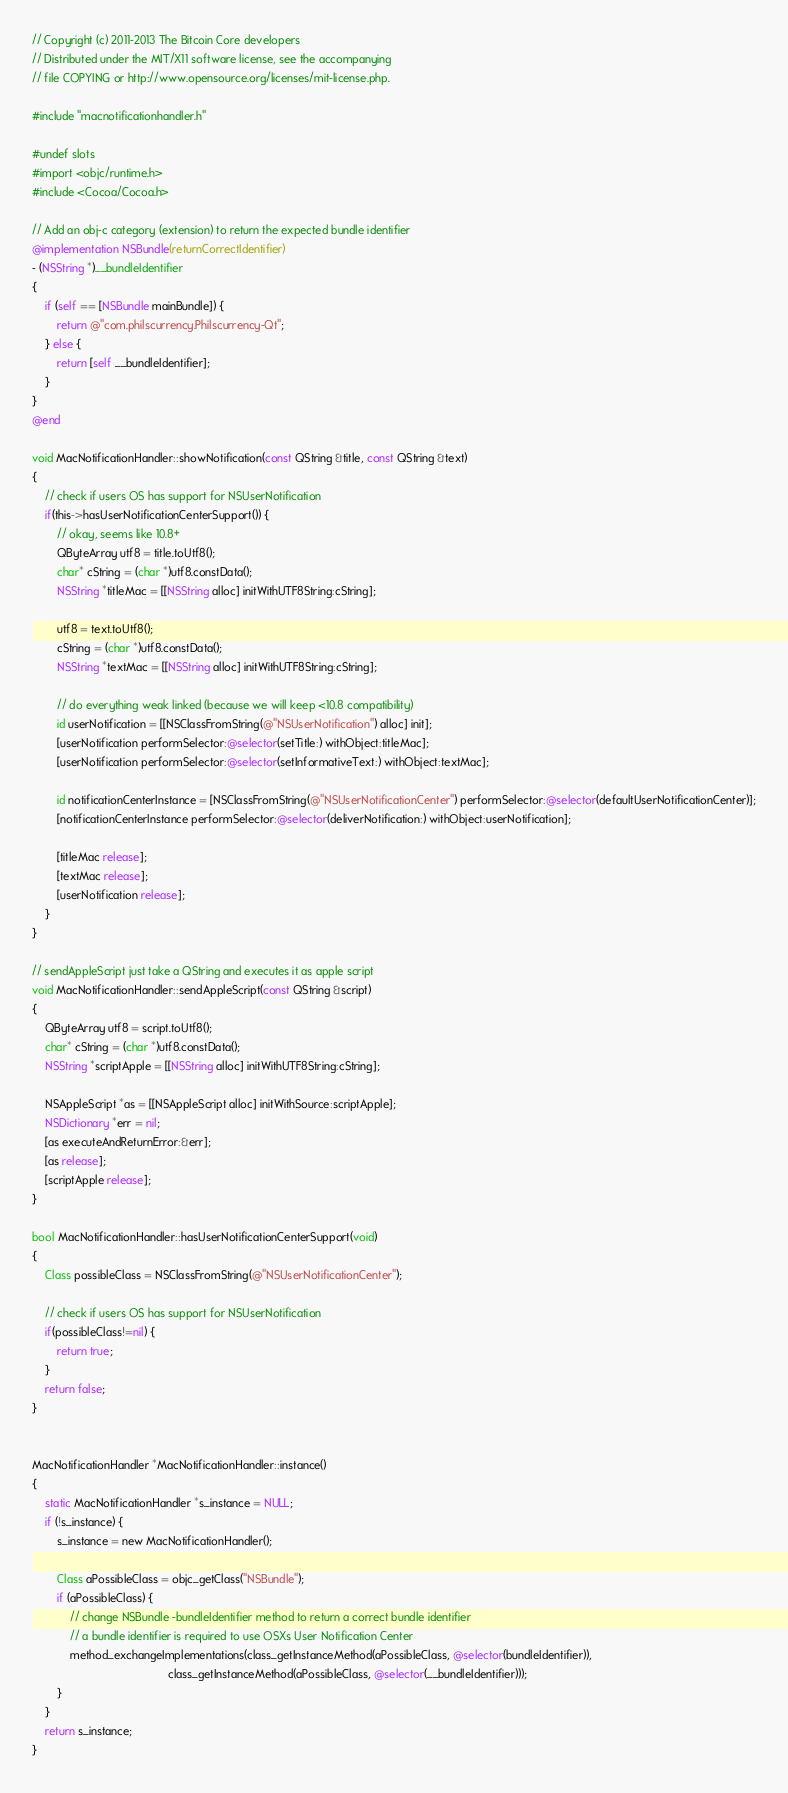<code> <loc_0><loc_0><loc_500><loc_500><_ObjectiveC_>// Copyright (c) 2011-2013 The Bitcoin Core developers
// Distributed under the MIT/X11 software license, see the accompanying
// file COPYING or http://www.opensource.org/licenses/mit-license.php.

#include "macnotificationhandler.h"

#undef slots
#import <objc/runtime.h>
#include <Cocoa/Cocoa.h>

// Add an obj-c category (extension) to return the expected bundle identifier
@implementation NSBundle(returnCorrectIdentifier)
- (NSString *)__bundleIdentifier
{
    if (self == [NSBundle mainBundle]) {
        return @"com.philscurrency.Philscurrency-Qt";
    } else {
        return [self __bundleIdentifier];
    }
}
@end

void MacNotificationHandler::showNotification(const QString &title, const QString &text)
{
    // check if users OS has support for NSUserNotification
    if(this->hasUserNotificationCenterSupport()) {
        // okay, seems like 10.8+
        QByteArray utf8 = title.toUtf8();
        char* cString = (char *)utf8.constData();
        NSString *titleMac = [[NSString alloc] initWithUTF8String:cString];

        utf8 = text.toUtf8();
        cString = (char *)utf8.constData();
        NSString *textMac = [[NSString alloc] initWithUTF8String:cString];

        // do everything weak linked (because we will keep <10.8 compatibility)
        id userNotification = [[NSClassFromString(@"NSUserNotification") alloc] init];
        [userNotification performSelector:@selector(setTitle:) withObject:titleMac];
        [userNotification performSelector:@selector(setInformativeText:) withObject:textMac];

        id notificationCenterInstance = [NSClassFromString(@"NSUserNotificationCenter") performSelector:@selector(defaultUserNotificationCenter)];
        [notificationCenterInstance performSelector:@selector(deliverNotification:) withObject:userNotification];

        [titleMac release];
        [textMac release];
        [userNotification release];
    }
}

// sendAppleScript just take a QString and executes it as apple script
void MacNotificationHandler::sendAppleScript(const QString &script)
{
    QByteArray utf8 = script.toUtf8();
    char* cString = (char *)utf8.constData();
    NSString *scriptApple = [[NSString alloc] initWithUTF8String:cString];

    NSAppleScript *as = [[NSAppleScript alloc] initWithSource:scriptApple];
    NSDictionary *err = nil;
    [as executeAndReturnError:&err];
    [as release];
    [scriptApple release];
}

bool MacNotificationHandler::hasUserNotificationCenterSupport(void)
{
    Class possibleClass = NSClassFromString(@"NSUserNotificationCenter");

    // check if users OS has support for NSUserNotification
    if(possibleClass!=nil) {
        return true;
    }
    return false;
}


MacNotificationHandler *MacNotificationHandler::instance()
{
    static MacNotificationHandler *s_instance = NULL;
    if (!s_instance) {
        s_instance = new MacNotificationHandler();
        
        Class aPossibleClass = objc_getClass("NSBundle");
        if (aPossibleClass) {
            // change NSBundle -bundleIdentifier method to return a correct bundle identifier
            // a bundle identifier is required to use OSXs User Notification Center
            method_exchangeImplementations(class_getInstanceMethod(aPossibleClass, @selector(bundleIdentifier)),
                                           class_getInstanceMethod(aPossibleClass, @selector(__bundleIdentifier)));
        }
    }
    return s_instance;
}
</code> 